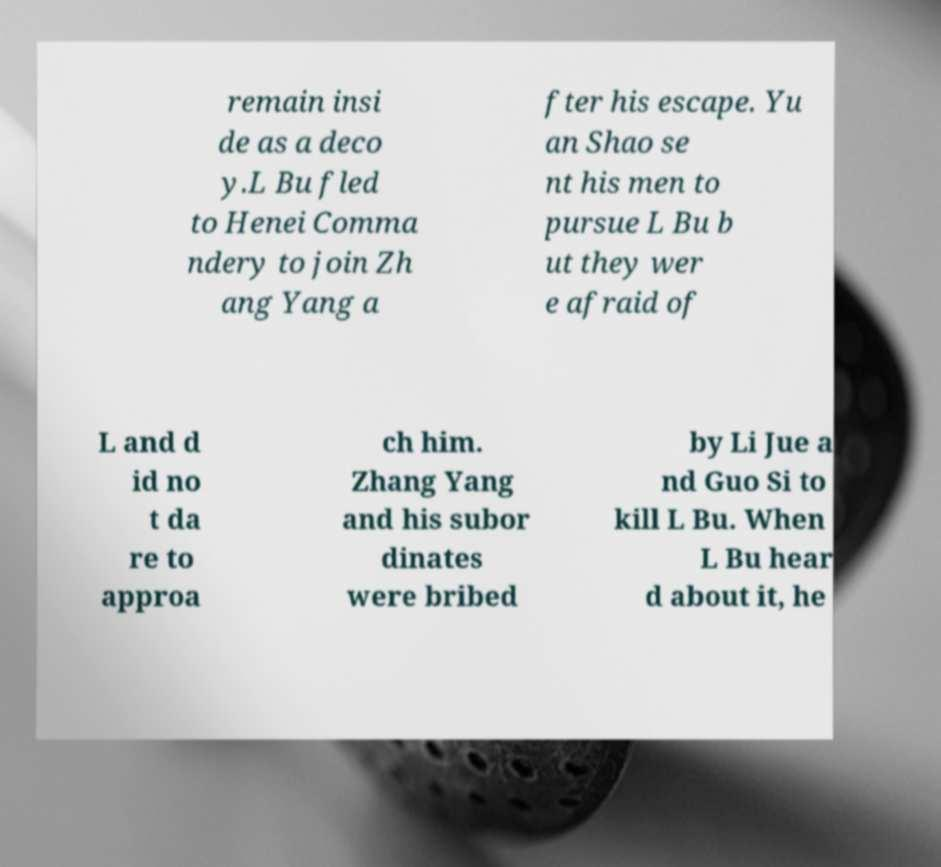Could you assist in decoding the text presented in this image and type it out clearly? remain insi de as a deco y.L Bu fled to Henei Comma ndery to join Zh ang Yang a fter his escape. Yu an Shao se nt his men to pursue L Bu b ut they wer e afraid of L and d id no t da re to approa ch him. Zhang Yang and his subor dinates were bribed by Li Jue a nd Guo Si to kill L Bu. When L Bu hear d about it, he 